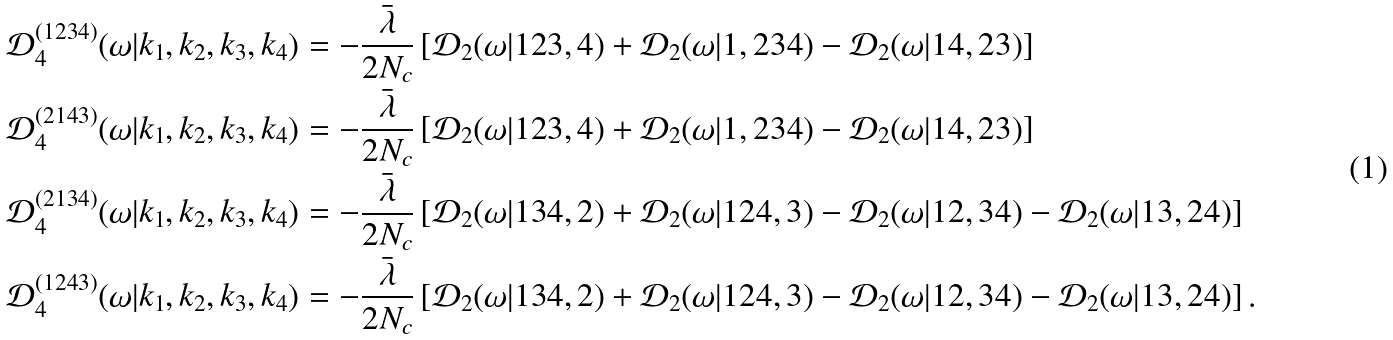<formula> <loc_0><loc_0><loc_500><loc_500>\mathcal { D } _ { 4 } ^ { ( 1 2 3 4 ) } ( \omega | { k } _ { 1 } , { k } _ { 2 } , { k } _ { 3 } , { k } _ { 4 } ) & = - \frac { \bar { \lambda } } { 2 N _ { c } } \left [ \mathcal { D } _ { 2 } ( \omega | 1 2 3 , 4 ) + \mathcal { D } _ { 2 } ( \omega | 1 , 2 3 4 ) - \mathcal { D } _ { 2 } ( \omega | 1 4 , 2 3 ) \right ] \\ \mathcal { D } _ { 4 } ^ { ( 2 1 4 3 ) } ( \omega | { k } _ { 1 } , { k } _ { 2 } , { k } _ { 3 } , { k } _ { 4 } ) & = - \frac { \bar { \lambda } } { 2 N _ { c } } \left [ \mathcal { D } _ { 2 } ( \omega | 1 2 3 , 4 ) + \mathcal { D } _ { 2 } ( \omega | 1 , 2 3 4 ) - \mathcal { D } _ { 2 } ( \omega | 1 4 , 2 3 ) \right ] \\ \mathcal { D } _ { 4 } ^ { ( 2 1 3 4 ) } ( \omega | { k } _ { 1 } , { k } _ { 2 } , { k } _ { 3 } , { k } _ { 4 } ) & = - \frac { \bar { \lambda } } { 2 N _ { c } } \left [ \mathcal { D } _ { 2 } ( \omega | 1 3 4 , 2 ) + \mathcal { D } _ { 2 } ( \omega | 1 2 4 , 3 ) - \mathcal { D } _ { 2 } ( \omega | 1 2 , 3 4 ) - \mathcal { D } _ { 2 } ( \omega | 1 3 , 2 4 ) \right ] \\ \mathcal { D } _ { 4 } ^ { ( 1 2 4 3 ) } ( \omega | { k } _ { 1 } , { k } _ { 2 } , { k } _ { 3 } , { k } _ { 4 } ) & = - \frac { \bar { \lambda } } { 2 N _ { c } } \left [ \mathcal { D } _ { 2 } ( \omega | 1 3 4 , 2 ) + \mathcal { D } _ { 2 } ( \omega | 1 2 4 , 3 ) - \mathcal { D } _ { 2 } ( \omega | 1 2 , 3 4 ) - \mathcal { D } _ { 2 } ( \omega | 1 3 , 2 4 ) \right ] .</formula> 